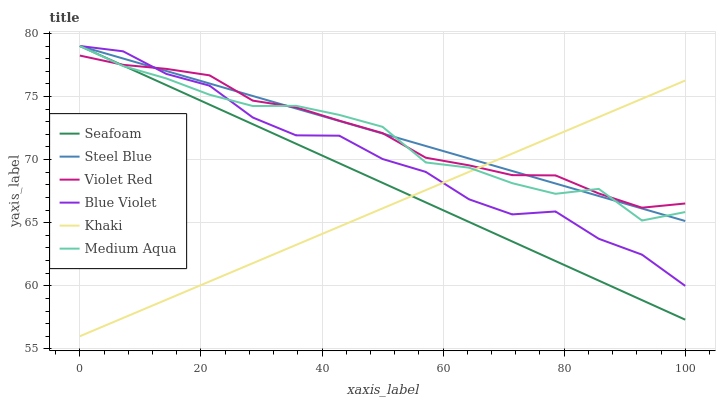Does Khaki have the minimum area under the curve?
Answer yes or no. Yes. Does Steel Blue have the maximum area under the curve?
Answer yes or no. Yes. Does Seafoam have the minimum area under the curve?
Answer yes or no. No. Does Seafoam have the maximum area under the curve?
Answer yes or no. No. Is Steel Blue the smoothest?
Answer yes or no. Yes. Is Blue Violet the roughest?
Answer yes or no. Yes. Is Khaki the smoothest?
Answer yes or no. No. Is Khaki the roughest?
Answer yes or no. No. Does Khaki have the lowest value?
Answer yes or no. Yes. Does Seafoam have the lowest value?
Answer yes or no. No. Does Blue Violet have the highest value?
Answer yes or no. Yes. Does Khaki have the highest value?
Answer yes or no. No. Does Steel Blue intersect Medium Aqua?
Answer yes or no. Yes. Is Steel Blue less than Medium Aqua?
Answer yes or no. No. Is Steel Blue greater than Medium Aqua?
Answer yes or no. No. 